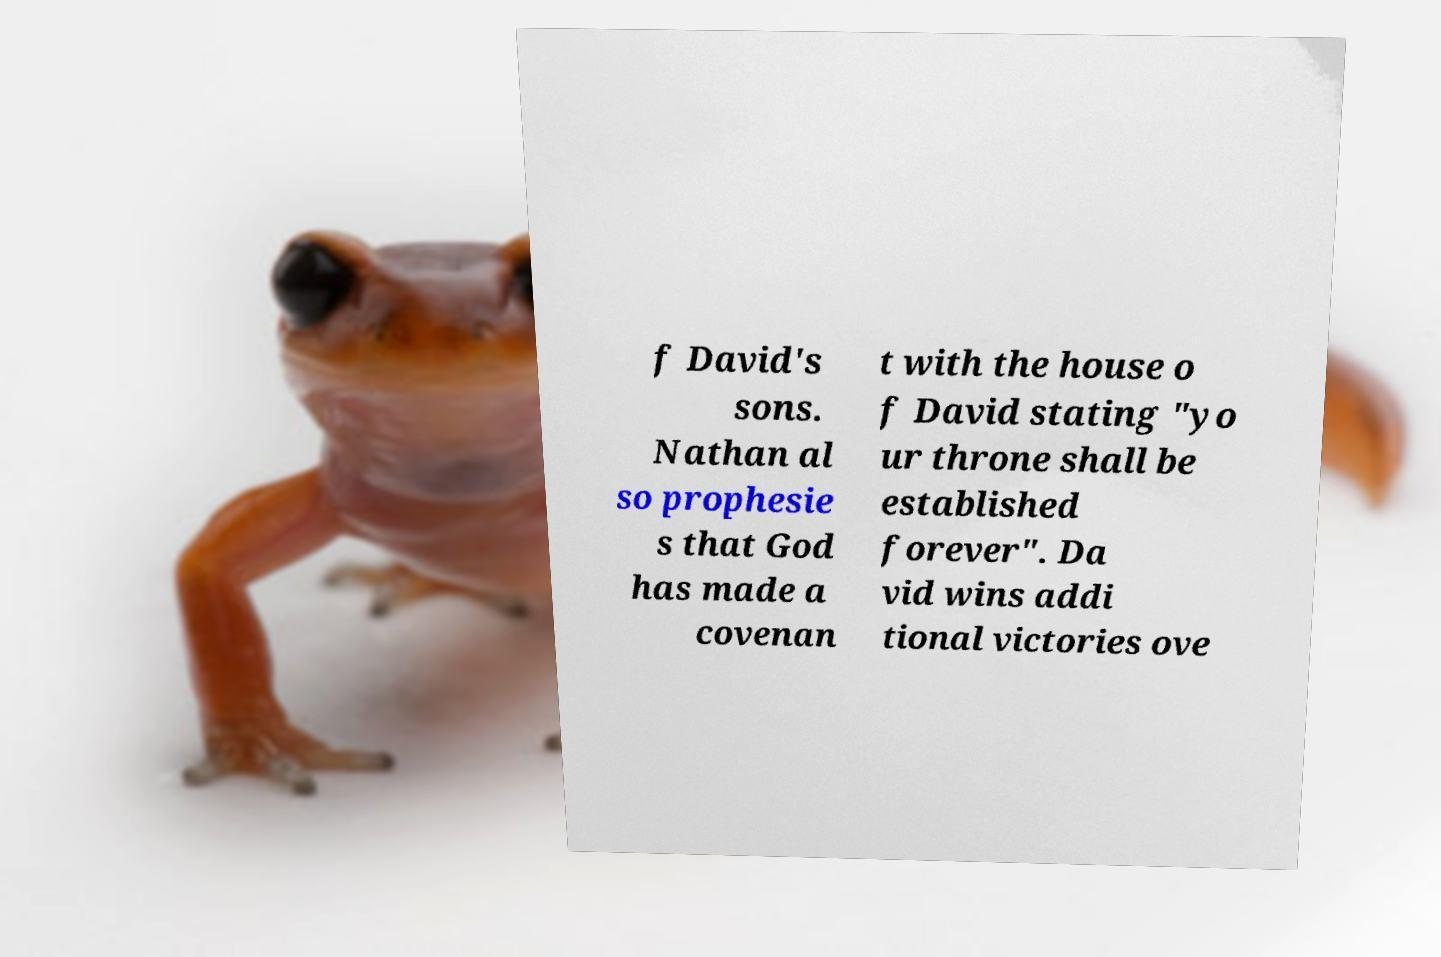What messages or text are displayed in this image? I need them in a readable, typed format. f David's sons. Nathan al so prophesie s that God has made a covenan t with the house o f David stating "yo ur throne shall be established forever". Da vid wins addi tional victories ove 